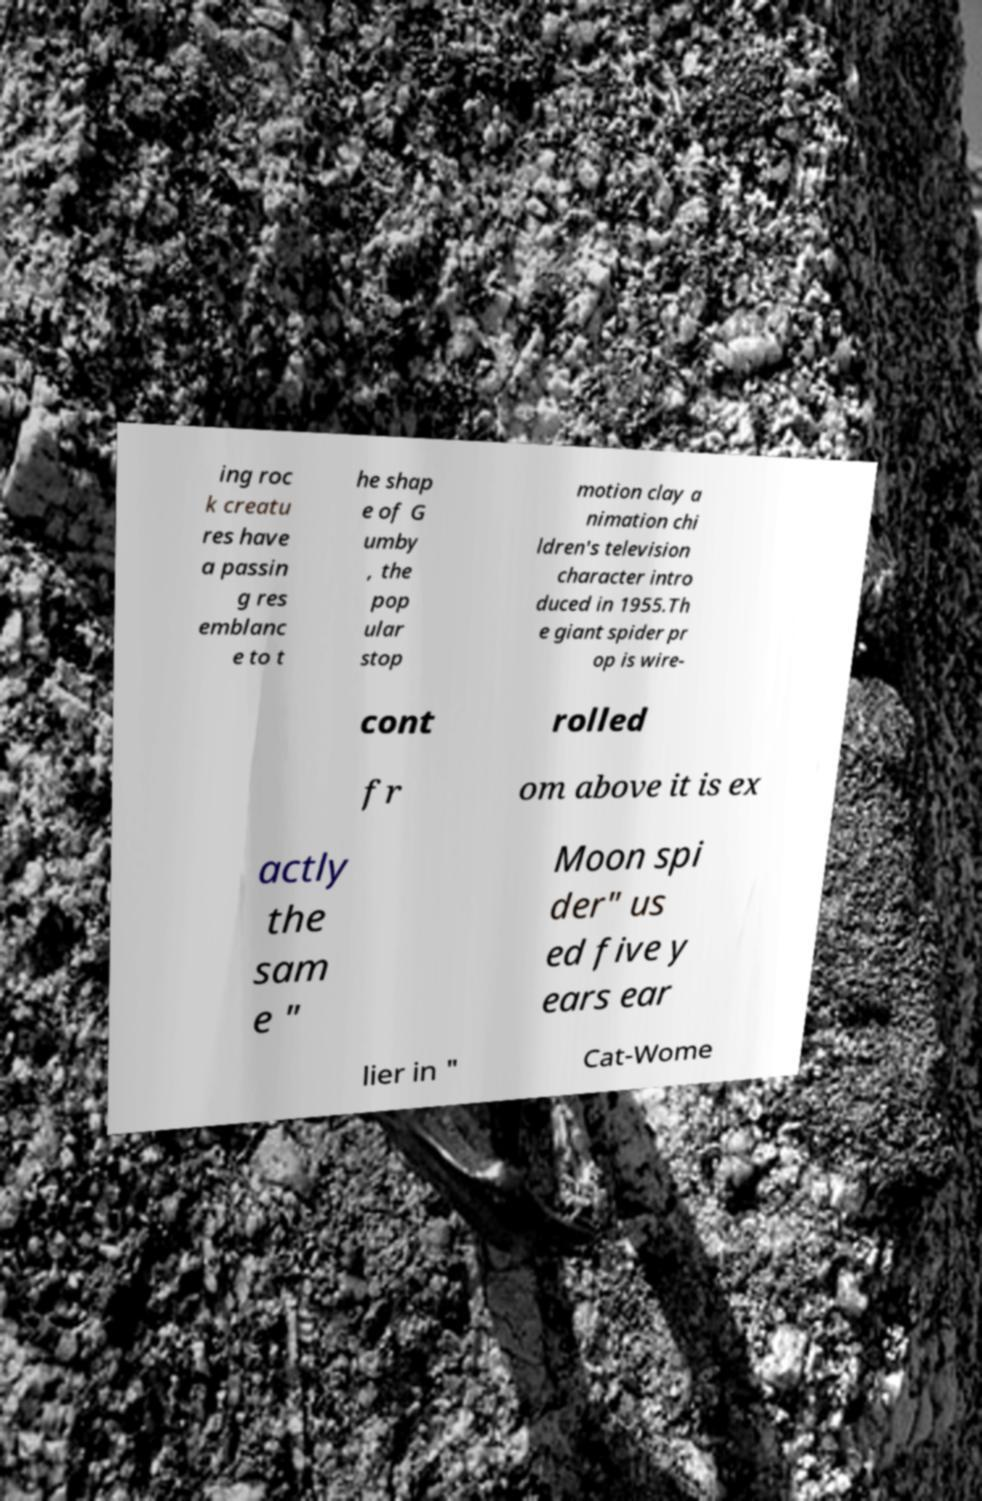There's text embedded in this image that I need extracted. Can you transcribe it verbatim? ing roc k creatu res have a passin g res emblanc e to t he shap e of G umby , the pop ular stop motion clay a nimation chi ldren's television character intro duced in 1955.Th e giant spider pr op is wire- cont rolled fr om above it is ex actly the sam e " Moon spi der" us ed five y ears ear lier in " Cat-Wome 